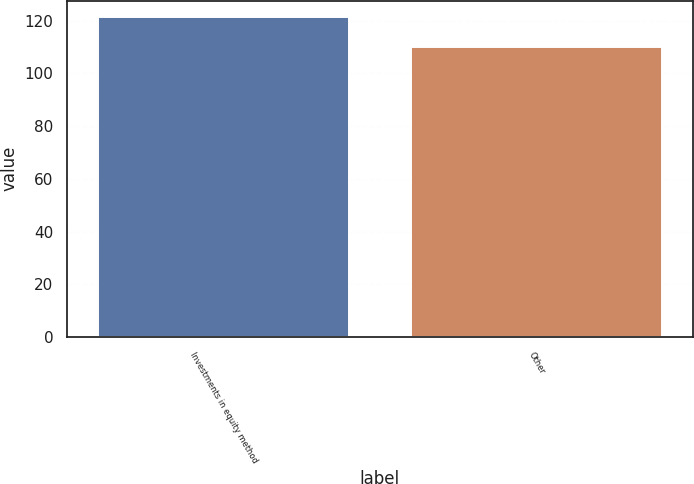Convert chart to OTSL. <chart><loc_0><loc_0><loc_500><loc_500><bar_chart><fcel>Investments in equity method<fcel>Other<nl><fcel>121.5<fcel>110<nl></chart> 